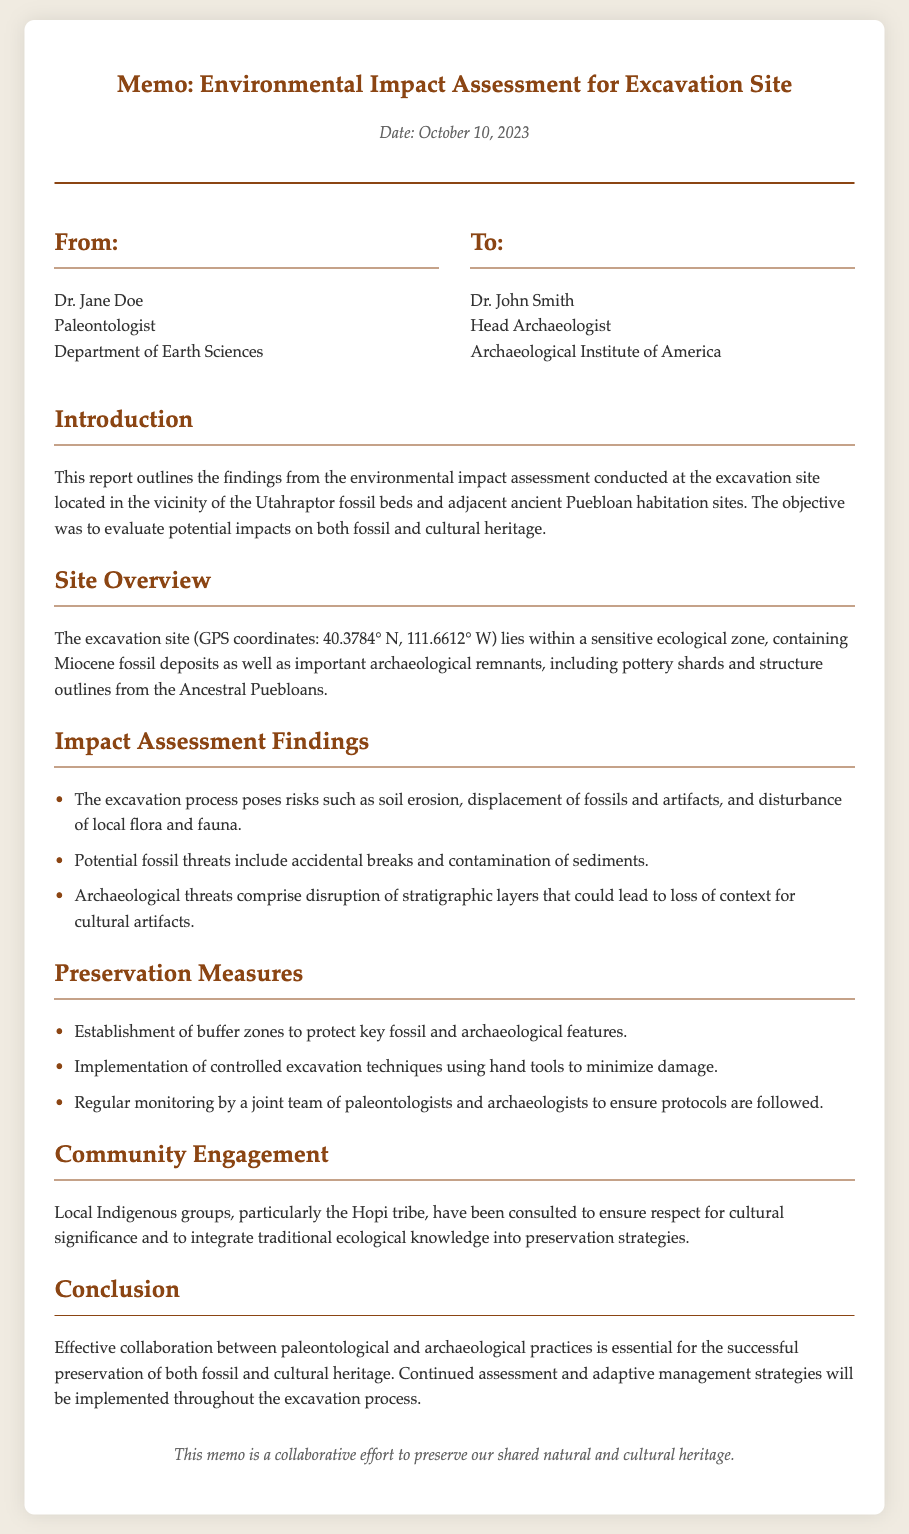What are the GPS coordinates of the excavation site? The GPS coordinates are specified in the document under the site overview section.
Answer: 40.3784° N, 111.6612° W Who authored the memo? The author is listed in the "From" section of the memo.
Answer: Dr. Jane Doe What type of deposits are found at the excavation site? The document mentions specific geological deposits in the site overview.
Answer: Miocene fossil deposits What is one potential threat to fossils mentioned in the report? The threats to fossils are listed in the "Impact Assessment Findings" section.
Answer: Accidental breaks Which Indigenous group was consulted for community engagement? The document states the group involved in community engagement in the respective section.
Answer: Hopi tribe What is one preservation measure implemented at the site? This information can be found in the "Preservation Measures" section of the memo.
Answer: Establishment of buffer zones What is the date of the memo? The date is indicated in the header area of the document.
Answer: October 10, 2023 What is the main objective of the environmental impact assessment? The objective can be found in the introduction of the memo.
Answer: Evaluate potential impacts on both fossil and cultural heritage 